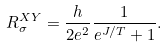<formula> <loc_0><loc_0><loc_500><loc_500>R _ { \sigma } ^ { X Y } = \frac { h } { 2 e ^ { 2 } } \frac { 1 } { e ^ { J / T } + 1 } .</formula> 